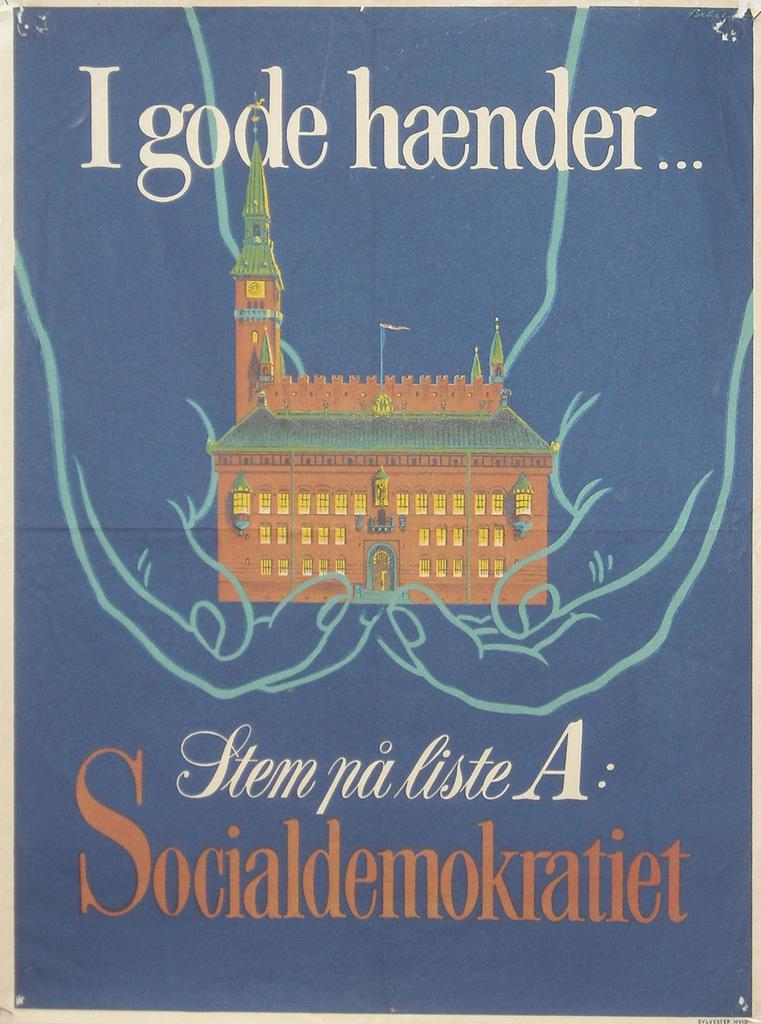Provide a one-sentence caption for the provided image. Cover showing a building and the words "Socialdemokratiet" on the bottom. 